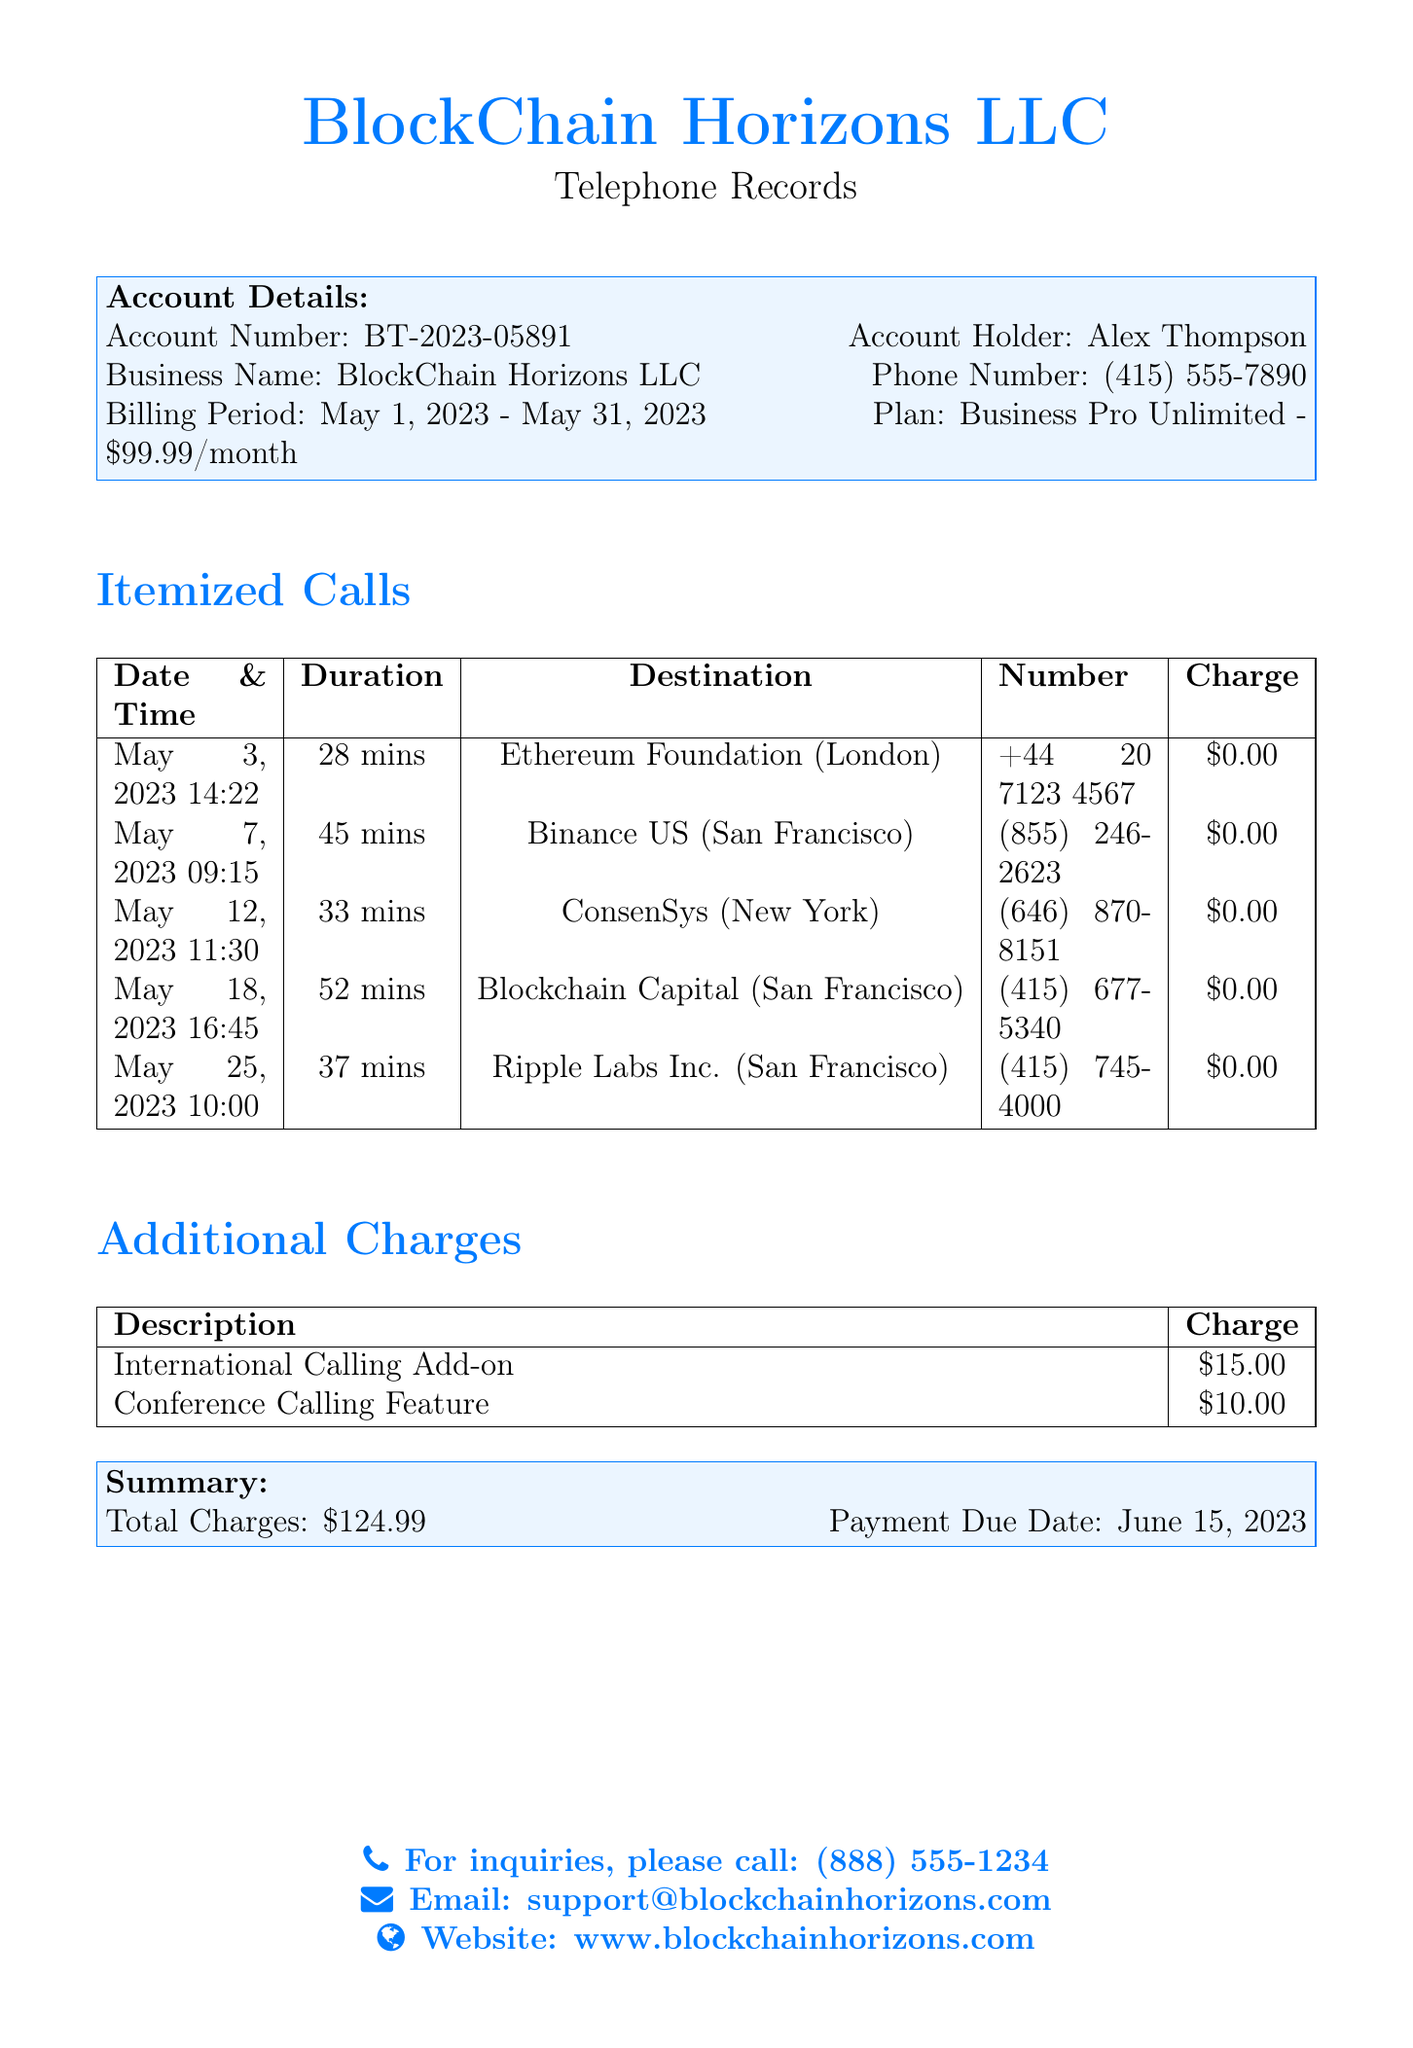What is the account number? The account number is listed under Account Details in the document.
Answer: BT-2023-05891 Who is the account holder? The account holder's name is found in the Account Details section.
Answer: Alex Thompson What is the phone number associated with the business? The phone number is mentioned in the Account Details.
Answer: (415) 555-7890 What is the total charge for the billing period? The total charge is summarized at the bottom of the document.
Answer: $124.99 How many minutes was the longest call? The longest duration can be found in the Itemized Calls table.
Answer: 52 mins What feature has an additional charge of $10.00? The additional charges section lists various features with their corresponding costs.
Answer: Conference Calling Feature Which calling feature has an additional fee? This information is retrieved from the Additional Charges section.
Answer: International Calling Add-on What was the billing period covered in this statement? The billing period is specified in the Account Details.
Answer: May 1, 2023 - May 31, 2023 When is the payment due date? The payment due date is stated in the Summary section of the document.
Answer: June 15, 2023 